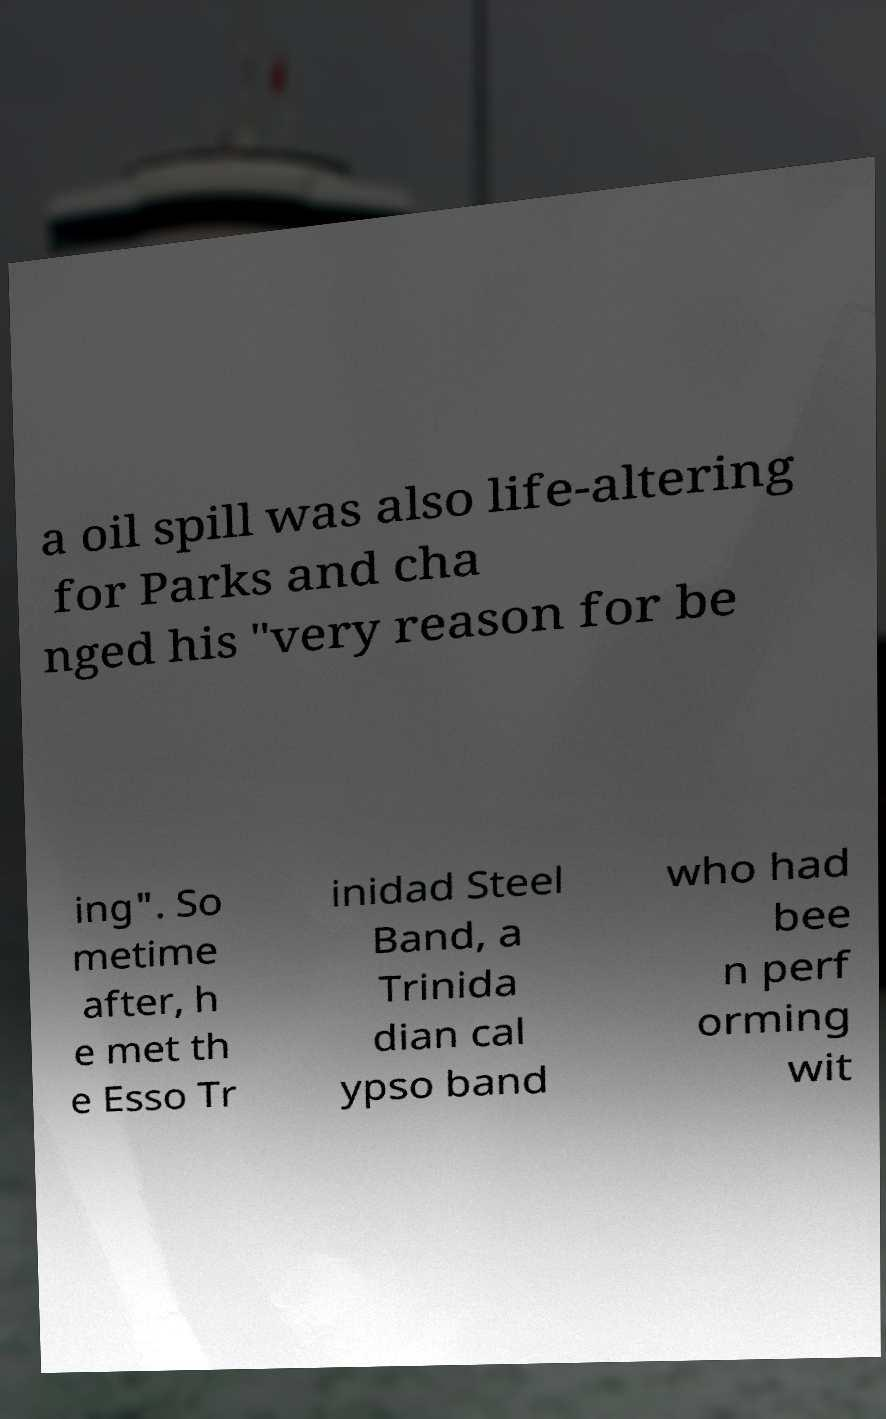Please read and relay the text visible in this image. What does it say? a oil spill was also life-altering for Parks and cha nged his "very reason for be ing". So metime after, h e met th e Esso Tr inidad Steel Band, a Trinida dian cal ypso band who had bee n perf orming wit 